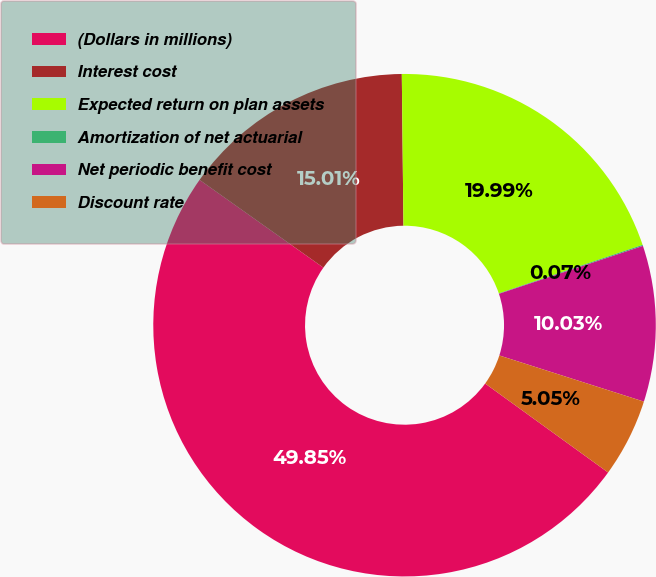<chart> <loc_0><loc_0><loc_500><loc_500><pie_chart><fcel>(Dollars in millions)<fcel>Interest cost<fcel>Expected return on plan assets<fcel>Amortization of net actuarial<fcel>Net periodic benefit cost<fcel>Discount rate<nl><fcel>49.85%<fcel>15.01%<fcel>19.99%<fcel>0.07%<fcel>10.03%<fcel>5.05%<nl></chart> 